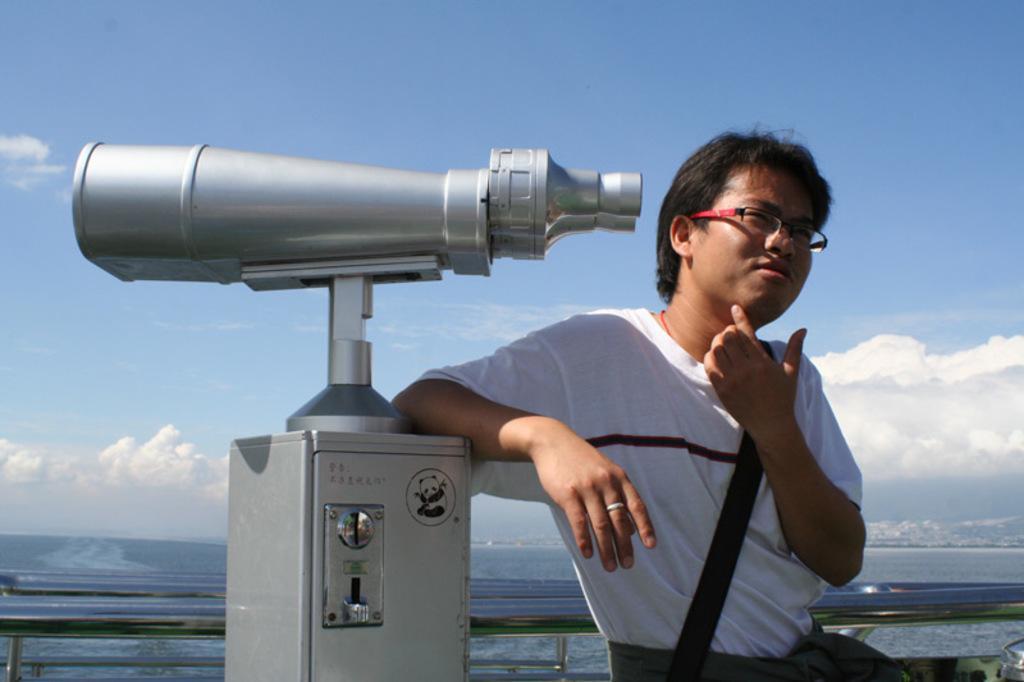Describe this image in one or two sentences. On the right side, there is a person in white color t-shirt, keeping his elbow on the silver color stand, on which there is a binocular. In the background, there is water and there are clouds in the sky. 